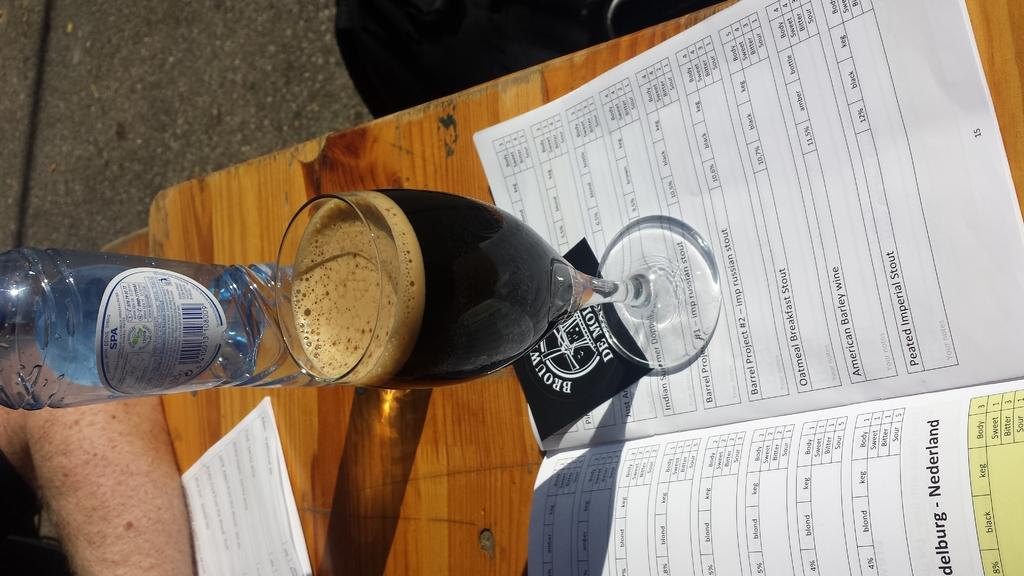What is one of the objects on the table in the image? There is a bottle in the image. What else can be seen on the table? There is a glass and a paper in the image. Can you describe the bottle in the image? The bottle has a sticker attached to it. What is the person's hand doing in the image? A person's hand is on the table. What type of beast can be seen in the image? There is no beast present in the image. What does the paper smell like in the image? The image does not provide any information about the smell of the paper. 